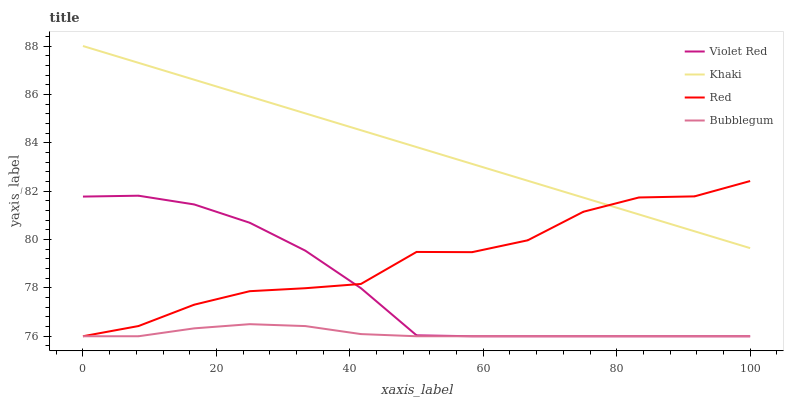Does Bubblegum have the minimum area under the curve?
Answer yes or no. Yes. Does Khaki have the maximum area under the curve?
Answer yes or no. Yes. Does Khaki have the minimum area under the curve?
Answer yes or no. No. Does Bubblegum have the maximum area under the curve?
Answer yes or no. No. Is Khaki the smoothest?
Answer yes or no. Yes. Is Red the roughest?
Answer yes or no. Yes. Is Bubblegum the smoothest?
Answer yes or no. No. Is Bubblegum the roughest?
Answer yes or no. No. Does Violet Red have the lowest value?
Answer yes or no. Yes. Does Khaki have the lowest value?
Answer yes or no. No. Does Khaki have the highest value?
Answer yes or no. Yes. Does Bubblegum have the highest value?
Answer yes or no. No. Is Bubblegum less than Khaki?
Answer yes or no. Yes. Is Khaki greater than Violet Red?
Answer yes or no. Yes. Does Red intersect Bubblegum?
Answer yes or no. Yes. Is Red less than Bubblegum?
Answer yes or no. No. Is Red greater than Bubblegum?
Answer yes or no. No. Does Bubblegum intersect Khaki?
Answer yes or no. No. 